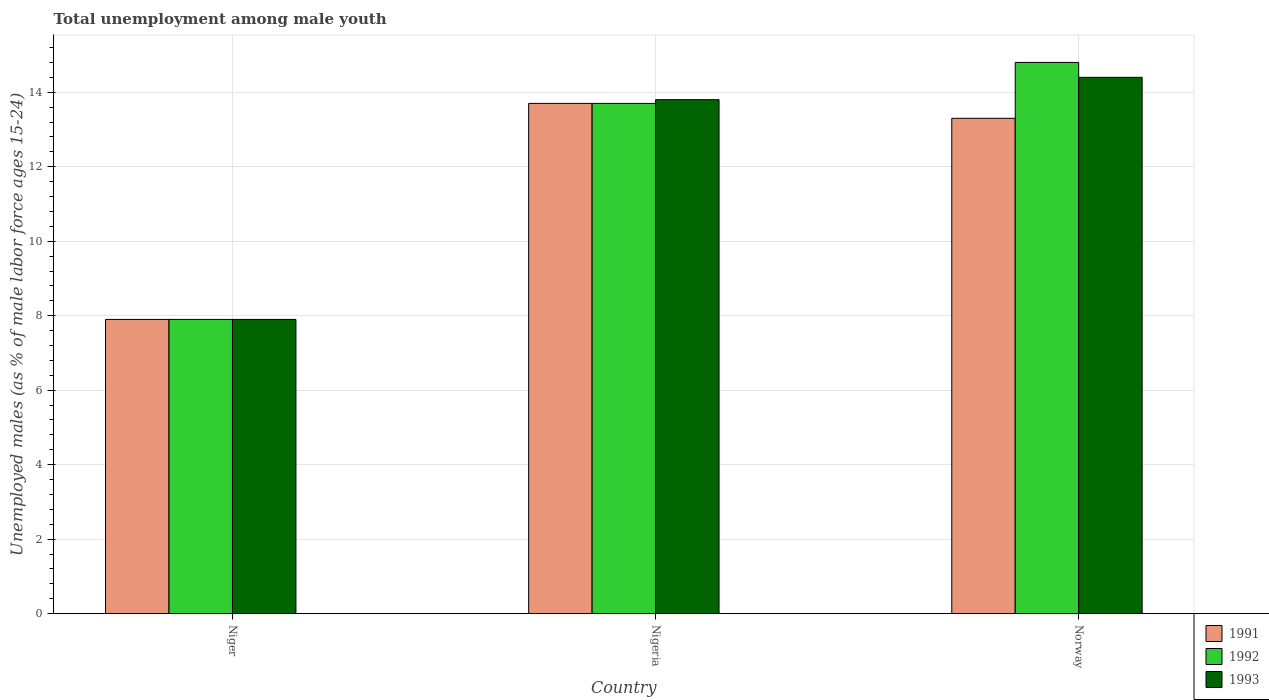Are the number of bars on each tick of the X-axis equal?
Provide a succinct answer. Yes. How many bars are there on the 1st tick from the left?
Offer a very short reply. 3. How many bars are there on the 3rd tick from the right?
Offer a terse response. 3. What is the label of the 1st group of bars from the left?
Your response must be concise. Niger. In how many cases, is the number of bars for a given country not equal to the number of legend labels?
Make the answer very short. 0. What is the percentage of unemployed males in in 1993 in Niger?
Provide a succinct answer. 7.9. Across all countries, what is the maximum percentage of unemployed males in in 1993?
Give a very brief answer. 14.4. Across all countries, what is the minimum percentage of unemployed males in in 1991?
Ensure brevity in your answer.  7.9. In which country was the percentage of unemployed males in in 1991 maximum?
Provide a succinct answer. Nigeria. In which country was the percentage of unemployed males in in 1993 minimum?
Ensure brevity in your answer.  Niger. What is the total percentage of unemployed males in in 1992 in the graph?
Your answer should be very brief. 36.4. What is the difference between the percentage of unemployed males in in 1993 in Nigeria and that in Norway?
Provide a succinct answer. -0.6. What is the difference between the percentage of unemployed males in in 1992 in Nigeria and the percentage of unemployed males in in 1991 in Niger?
Offer a terse response. 5.8. What is the average percentage of unemployed males in in 1993 per country?
Your answer should be very brief. 12.03. In how many countries, is the percentage of unemployed males in in 1992 greater than 10.4 %?
Your answer should be very brief. 2. What is the ratio of the percentage of unemployed males in in 1991 in Nigeria to that in Norway?
Make the answer very short. 1.03. Is the difference between the percentage of unemployed males in in 1992 in Nigeria and Norway greater than the difference between the percentage of unemployed males in in 1991 in Nigeria and Norway?
Your answer should be very brief. No. What is the difference between the highest and the second highest percentage of unemployed males in in 1993?
Your response must be concise. -0.6. What is the difference between the highest and the lowest percentage of unemployed males in in 1992?
Provide a short and direct response. 6.9. Is the sum of the percentage of unemployed males in in 1992 in Nigeria and Norway greater than the maximum percentage of unemployed males in in 1993 across all countries?
Your answer should be compact. Yes. Is it the case that in every country, the sum of the percentage of unemployed males in in 1991 and percentage of unemployed males in in 1993 is greater than the percentage of unemployed males in in 1992?
Give a very brief answer. Yes. How many bars are there?
Give a very brief answer. 9. Are the values on the major ticks of Y-axis written in scientific E-notation?
Provide a short and direct response. No. Does the graph contain any zero values?
Your answer should be very brief. No. Where does the legend appear in the graph?
Provide a succinct answer. Bottom right. How are the legend labels stacked?
Your answer should be very brief. Vertical. What is the title of the graph?
Make the answer very short. Total unemployment among male youth. What is the label or title of the X-axis?
Offer a very short reply. Country. What is the label or title of the Y-axis?
Offer a terse response. Unemployed males (as % of male labor force ages 15-24). What is the Unemployed males (as % of male labor force ages 15-24) in 1991 in Niger?
Make the answer very short. 7.9. What is the Unemployed males (as % of male labor force ages 15-24) in 1992 in Niger?
Provide a succinct answer. 7.9. What is the Unemployed males (as % of male labor force ages 15-24) in 1993 in Niger?
Provide a succinct answer. 7.9. What is the Unemployed males (as % of male labor force ages 15-24) in 1991 in Nigeria?
Provide a short and direct response. 13.7. What is the Unemployed males (as % of male labor force ages 15-24) in 1992 in Nigeria?
Keep it short and to the point. 13.7. What is the Unemployed males (as % of male labor force ages 15-24) of 1993 in Nigeria?
Offer a terse response. 13.8. What is the Unemployed males (as % of male labor force ages 15-24) in 1991 in Norway?
Your response must be concise. 13.3. What is the Unemployed males (as % of male labor force ages 15-24) in 1992 in Norway?
Your answer should be compact. 14.8. What is the Unemployed males (as % of male labor force ages 15-24) in 1993 in Norway?
Ensure brevity in your answer.  14.4. Across all countries, what is the maximum Unemployed males (as % of male labor force ages 15-24) of 1991?
Offer a very short reply. 13.7. Across all countries, what is the maximum Unemployed males (as % of male labor force ages 15-24) of 1992?
Offer a terse response. 14.8. Across all countries, what is the maximum Unemployed males (as % of male labor force ages 15-24) in 1993?
Give a very brief answer. 14.4. Across all countries, what is the minimum Unemployed males (as % of male labor force ages 15-24) in 1991?
Your answer should be very brief. 7.9. Across all countries, what is the minimum Unemployed males (as % of male labor force ages 15-24) of 1992?
Offer a very short reply. 7.9. Across all countries, what is the minimum Unemployed males (as % of male labor force ages 15-24) of 1993?
Offer a very short reply. 7.9. What is the total Unemployed males (as % of male labor force ages 15-24) in 1991 in the graph?
Offer a terse response. 34.9. What is the total Unemployed males (as % of male labor force ages 15-24) of 1992 in the graph?
Provide a succinct answer. 36.4. What is the total Unemployed males (as % of male labor force ages 15-24) in 1993 in the graph?
Give a very brief answer. 36.1. What is the difference between the Unemployed males (as % of male labor force ages 15-24) of 1992 in Niger and that in Norway?
Offer a terse response. -6.9. What is the difference between the Unemployed males (as % of male labor force ages 15-24) in 1993 in Niger and that in Norway?
Your response must be concise. -6.5. What is the difference between the Unemployed males (as % of male labor force ages 15-24) in 1993 in Nigeria and that in Norway?
Provide a short and direct response. -0.6. What is the difference between the Unemployed males (as % of male labor force ages 15-24) of 1991 in Niger and the Unemployed males (as % of male labor force ages 15-24) of 1992 in Nigeria?
Ensure brevity in your answer.  -5.8. What is the difference between the Unemployed males (as % of male labor force ages 15-24) of 1991 in Niger and the Unemployed males (as % of male labor force ages 15-24) of 1993 in Nigeria?
Make the answer very short. -5.9. What is the difference between the Unemployed males (as % of male labor force ages 15-24) of 1991 in Niger and the Unemployed males (as % of male labor force ages 15-24) of 1992 in Norway?
Keep it short and to the point. -6.9. What is the difference between the Unemployed males (as % of male labor force ages 15-24) of 1992 in Niger and the Unemployed males (as % of male labor force ages 15-24) of 1993 in Norway?
Your response must be concise. -6.5. What is the difference between the Unemployed males (as % of male labor force ages 15-24) of 1992 in Nigeria and the Unemployed males (as % of male labor force ages 15-24) of 1993 in Norway?
Provide a short and direct response. -0.7. What is the average Unemployed males (as % of male labor force ages 15-24) of 1991 per country?
Provide a succinct answer. 11.63. What is the average Unemployed males (as % of male labor force ages 15-24) of 1992 per country?
Offer a very short reply. 12.13. What is the average Unemployed males (as % of male labor force ages 15-24) of 1993 per country?
Provide a short and direct response. 12.03. What is the difference between the Unemployed males (as % of male labor force ages 15-24) in 1991 and Unemployed males (as % of male labor force ages 15-24) in 1993 in Nigeria?
Your answer should be very brief. -0.1. What is the difference between the Unemployed males (as % of male labor force ages 15-24) in 1992 and Unemployed males (as % of male labor force ages 15-24) in 1993 in Nigeria?
Your response must be concise. -0.1. What is the difference between the Unemployed males (as % of male labor force ages 15-24) of 1991 and Unemployed males (as % of male labor force ages 15-24) of 1992 in Norway?
Offer a terse response. -1.5. What is the ratio of the Unemployed males (as % of male labor force ages 15-24) of 1991 in Niger to that in Nigeria?
Make the answer very short. 0.58. What is the ratio of the Unemployed males (as % of male labor force ages 15-24) of 1992 in Niger to that in Nigeria?
Offer a very short reply. 0.58. What is the ratio of the Unemployed males (as % of male labor force ages 15-24) in 1993 in Niger to that in Nigeria?
Your answer should be very brief. 0.57. What is the ratio of the Unemployed males (as % of male labor force ages 15-24) of 1991 in Niger to that in Norway?
Ensure brevity in your answer.  0.59. What is the ratio of the Unemployed males (as % of male labor force ages 15-24) of 1992 in Niger to that in Norway?
Your answer should be very brief. 0.53. What is the ratio of the Unemployed males (as % of male labor force ages 15-24) in 1993 in Niger to that in Norway?
Your answer should be very brief. 0.55. What is the ratio of the Unemployed males (as % of male labor force ages 15-24) in 1991 in Nigeria to that in Norway?
Offer a very short reply. 1.03. What is the ratio of the Unemployed males (as % of male labor force ages 15-24) of 1992 in Nigeria to that in Norway?
Your answer should be compact. 0.93. What is the ratio of the Unemployed males (as % of male labor force ages 15-24) in 1993 in Nigeria to that in Norway?
Provide a succinct answer. 0.96. What is the difference between the highest and the second highest Unemployed males (as % of male labor force ages 15-24) in 1993?
Keep it short and to the point. 0.6. What is the difference between the highest and the lowest Unemployed males (as % of male labor force ages 15-24) in 1993?
Your answer should be compact. 6.5. 